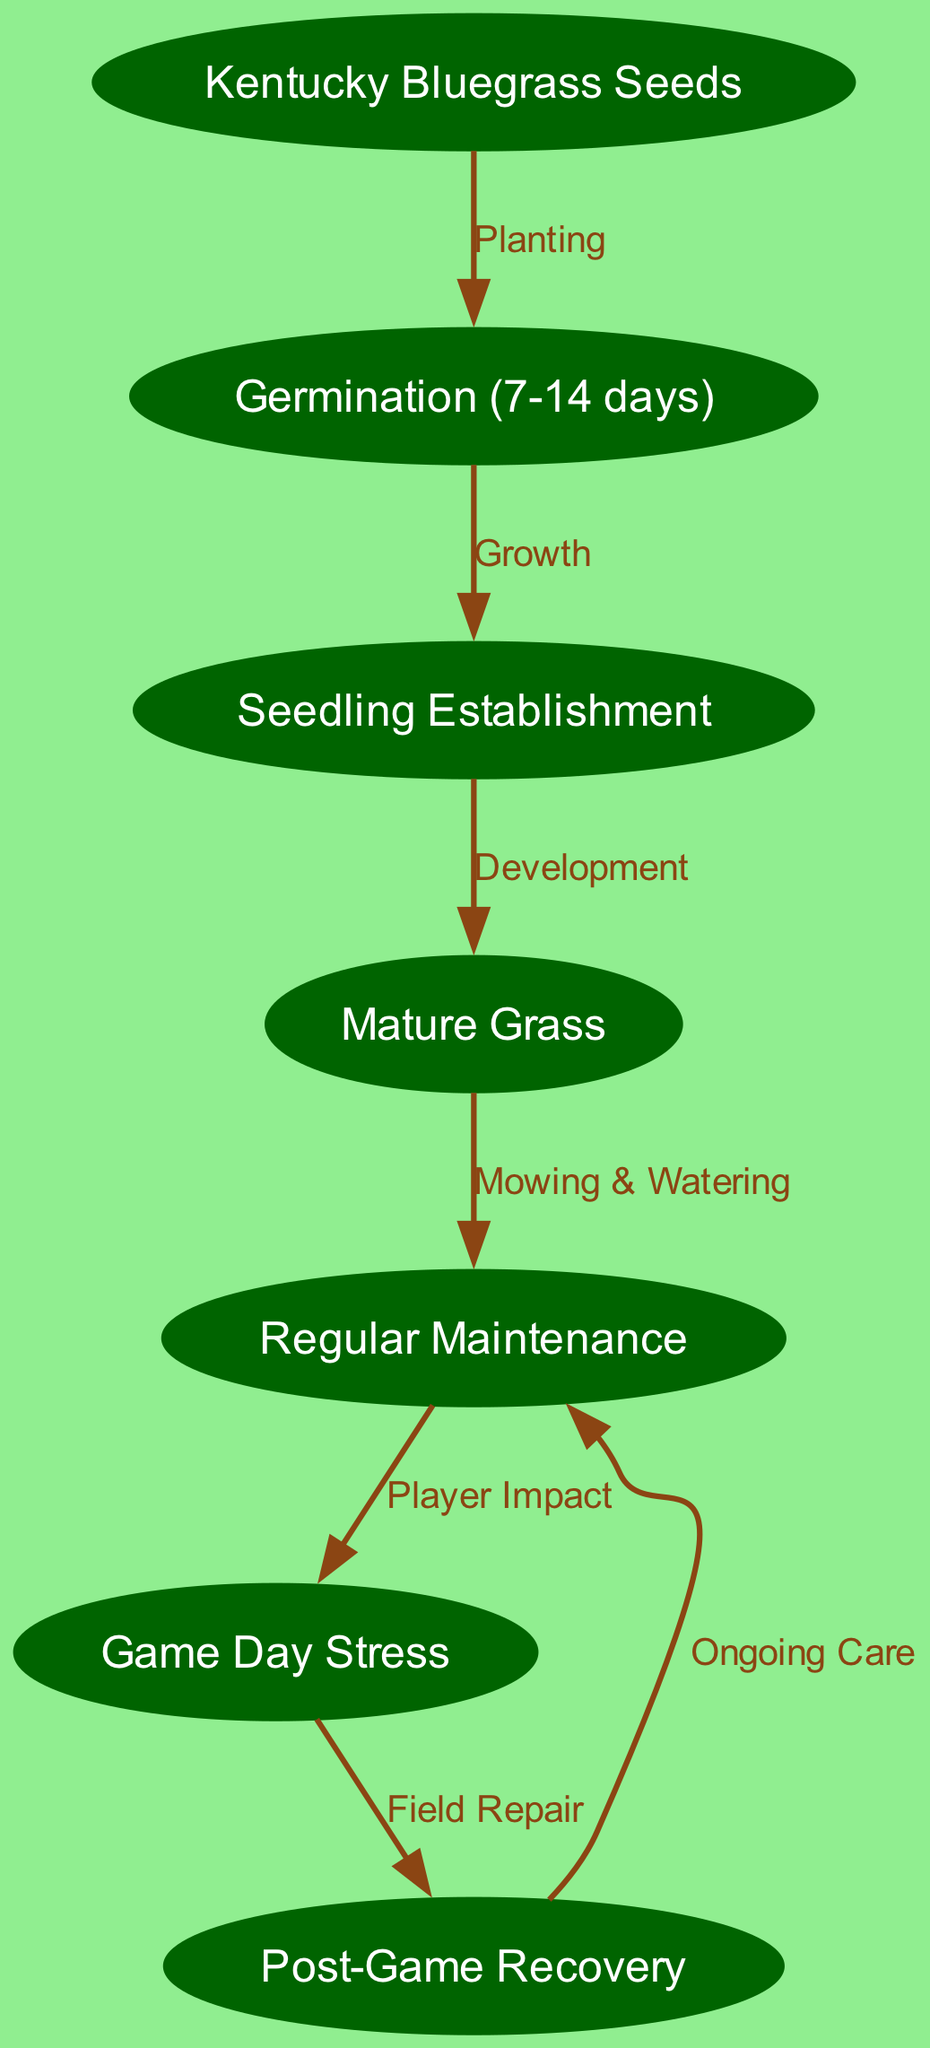What is the first stage in the life cycle? The diagram starts with the "Kentucky Bluegrass Seeds" node, which represents the initial stage of the grass life cycle.
Answer: Kentucky Bluegrass Seeds How long does germination take? The "Germination" node specifies the duration of this stage as 7-14 days.
Answer: 7-14 days What connects the seedling stage to the mature stage? The edge labeled "Development" connects the "Seedling Establishment" node to the "Mature Grass" node, indicating the transition from one stage to the next.
Answer: Development What type of maintenance follows mature grass? The diagram indicates that "Mowing & Watering" is required as maintenance after the "Mature Grass" stage.
Answer: Mowing & Watering How does game day affect the grass? "Game Day Stress" is a node that follows from "Regular Maintenance," indicating that player activities impact the grass during games.
Answer: Game Day Stress What leads to the need for field repair? The diagram shows an edge from the "Game Day Stress" to the "Post-Game Recovery" indicating that stress leads to the need for recovery and repair.
Answer: Field Repair How many total stages are there in the life cycle? Counting the nodes in the diagram, there are a total of 7 distinct stages from seeds to maintenance.
Answer: 7 What is the final process in the cycle? The diagram shows that "Ongoing Care" follows the "Post-Game Recovery," making it the last node in the cycle.
Answer: Ongoing Care What is the term for the maintenance process on game days? The diagram specifies "Player Impact" in relation to the maintenance process during game days.
Answer: Player Impact What node comes after regular maintenance? The next node after "Regular Maintenance" is "Game Day Stress," indicating the potential impact of games on the grass.
Answer: Game Day Stress 